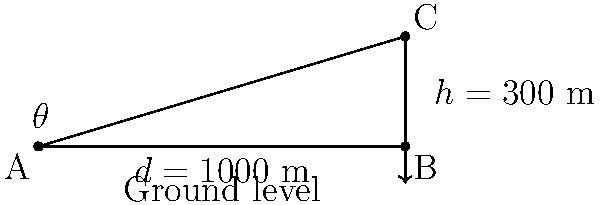During a trek in the Knuckles Mountain Range of Sri Lanka, you spot a distant peak. Using your altimeter, you determine that the peak is 300 meters higher than your current position. You estimate the horizontal distance to the peak to be 1000 meters. What is the angle of elevation (θ) to the peak from your viewpoint? To solve this problem, we'll use trigonometry, specifically the tangent function. Let's approach this step-by-step:

1) In the right-angled triangle ABC:
   - AB represents the horizontal distance (d) = 1000 m
   - BC represents the height difference (h) = 300 m
   - Angle θ at A is what we need to find

2) The tangent of an angle in a right-angled triangle is the ratio of the opposite side to the adjacent side:

   $$\tan \theta = \frac{\text{opposite}}{\text{adjacent}} = \frac{h}{d}$$

3) Substituting our known values:

   $$\tan \theta = \frac{300}{1000} = 0.3$$

4) To find θ, we need to use the inverse tangent function (arctan or tan^(-1)):

   $$\theta = \tan^{-1}(0.3)$$

5) Using a calculator or mathematical tables:

   $$\theta \approx 16.70^\circ$$

Therefore, the angle of elevation to the mountain peak is approximately 16.70°.
Answer: $16.70^\circ$ 